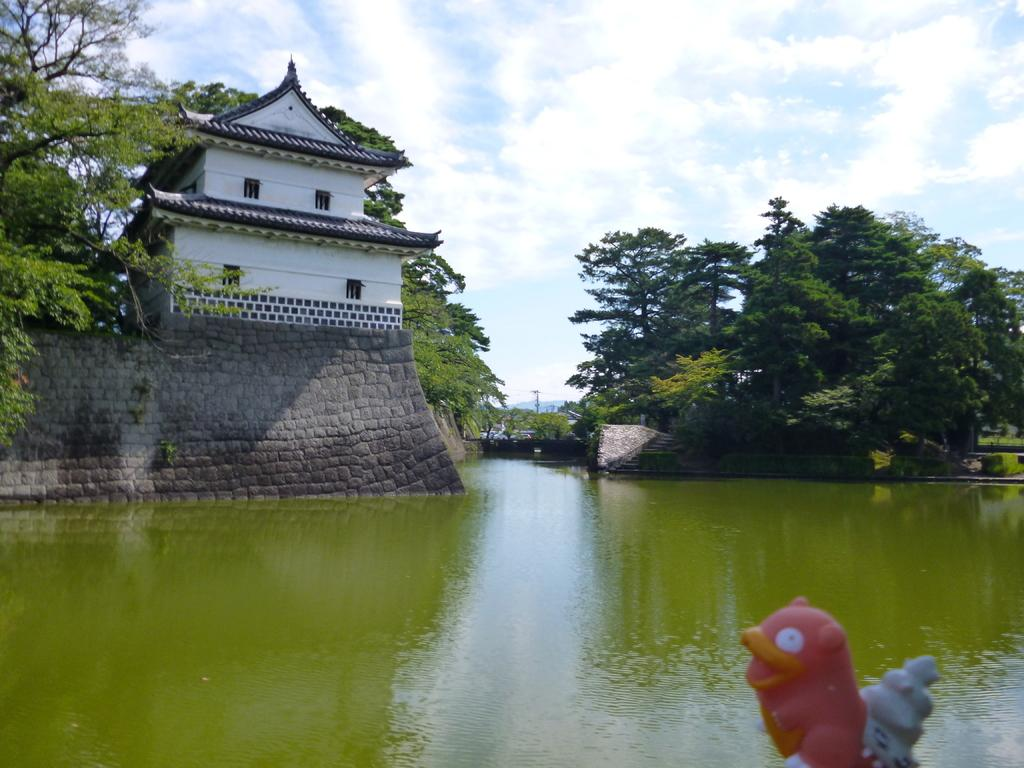What can be seen in the sky in the image? The sky with clouds is visible in the image. What type of natural elements are present in the image? There are trees in the image. What man-made structures can be seen in the image? There are buildings in the image. What type of wall is featured in the image? There are walls with pebble stones in the image. What is the presence of water in the image indicative of? Water is present in the image, which could suggest a body of water, a fountain, or a water feature. What type of error can be seen in the image? There is no error present in the image. What is the jar used for in the image? There is no jar present in the image. 